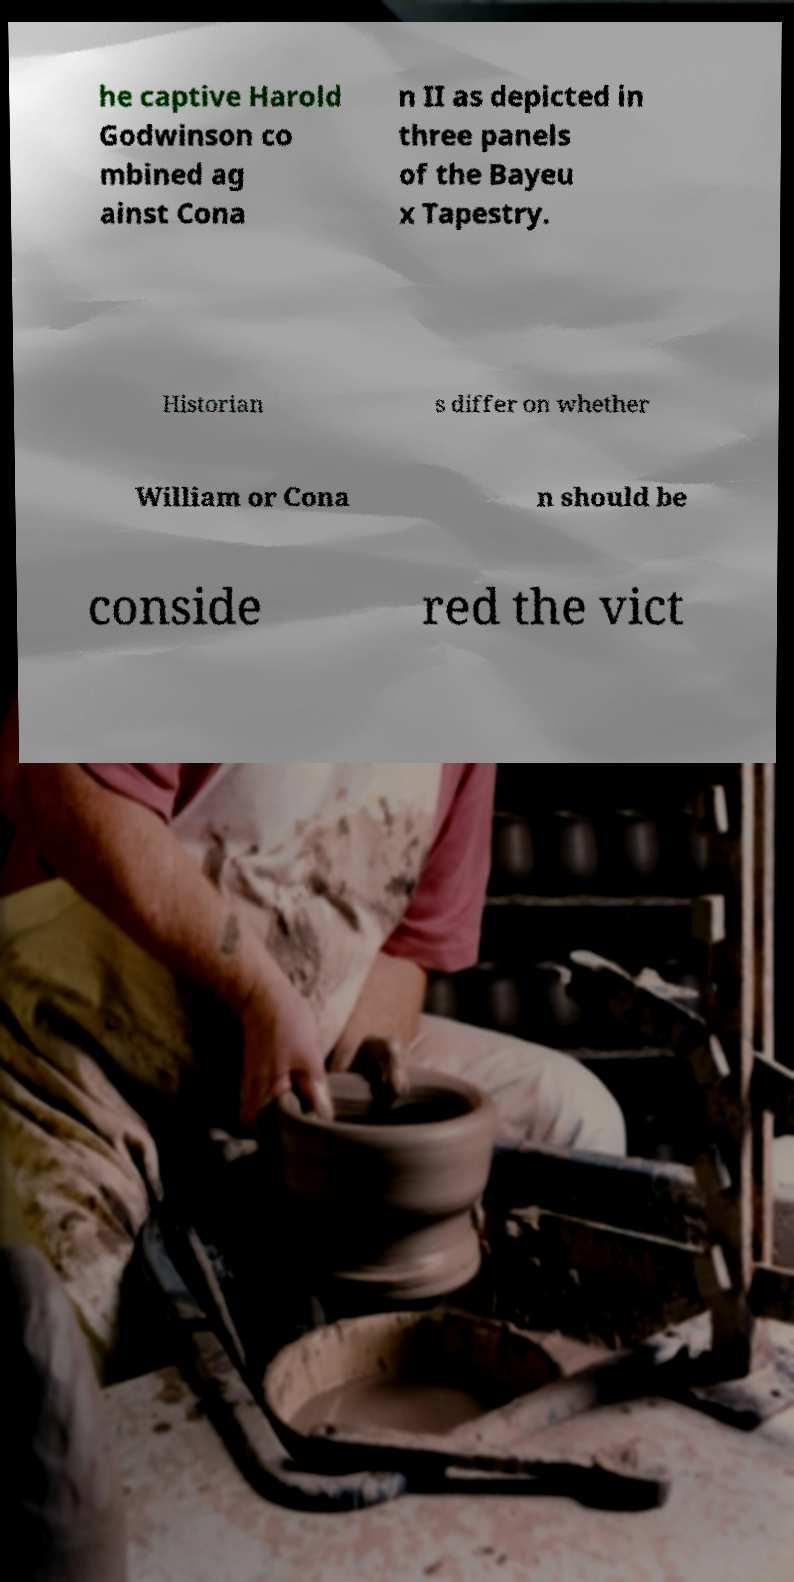Please identify and transcribe the text found in this image. he captive Harold Godwinson co mbined ag ainst Cona n II as depicted in three panels of the Bayeu x Tapestry. Historian s differ on whether William or Cona n should be conside red the vict 